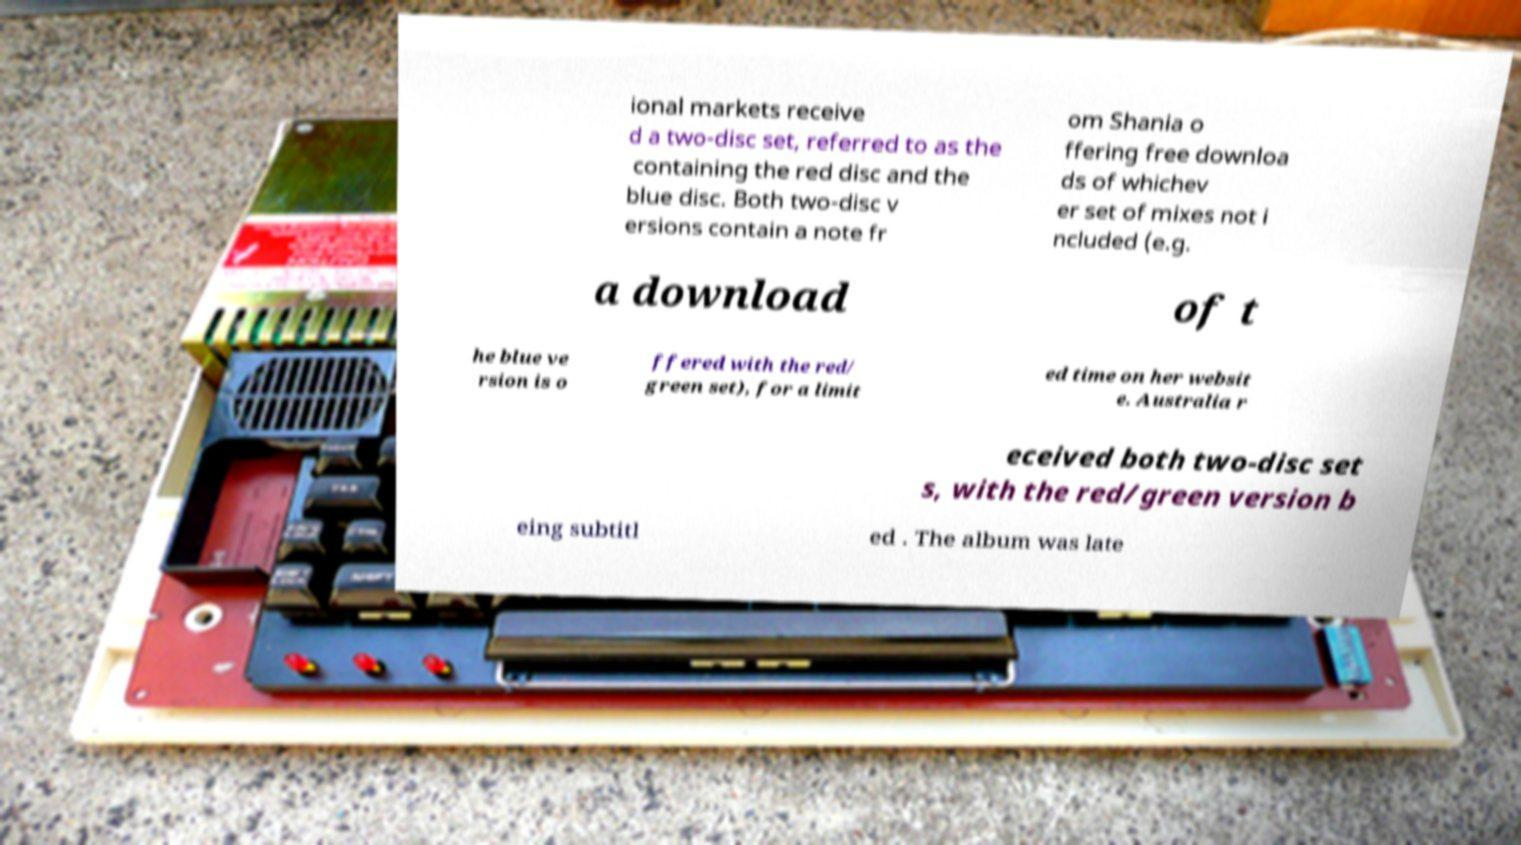Please read and relay the text visible in this image. What does it say? ional markets receive d a two-disc set, referred to as the containing the red disc and the blue disc. Both two-disc v ersions contain a note fr om Shania o ffering free downloa ds of whichev er set of mixes not i ncluded (e.g. a download of t he blue ve rsion is o ffered with the red/ green set), for a limit ed time on her websit e. Australia r eceived both two-disc set s, with the red/green version b eing subtitl ed . The album was late 